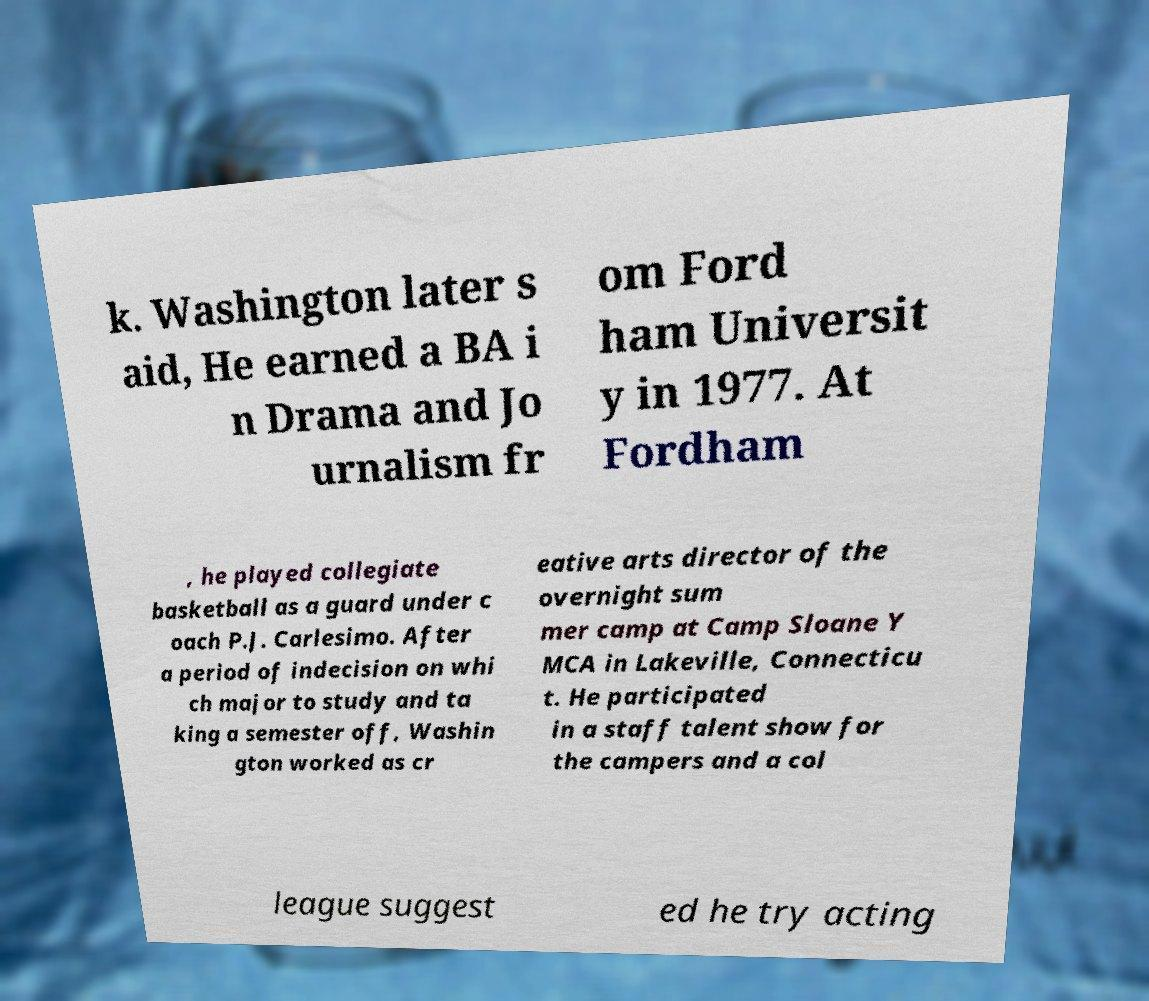There's text embedded in this image that I need extracted. Can you transcribe it verbatim? k. Washington later s aid, He earned a BA i n Drama and Jo urnalism fr om Ford ham Universit y in 1977. At Fordham , he played collegiate basketball as a guard under c oach P.J. Carlesimo. After a period of indecision on whi ch major to study and ta king a semester off, Washin gton worked as cr eative arts director of the overnight sum mer camp at Camp Sloane Y MCA in Lakeville, Connecticu t. He participated in a staff talent show for the campers and a col league suggest ed he try acting 